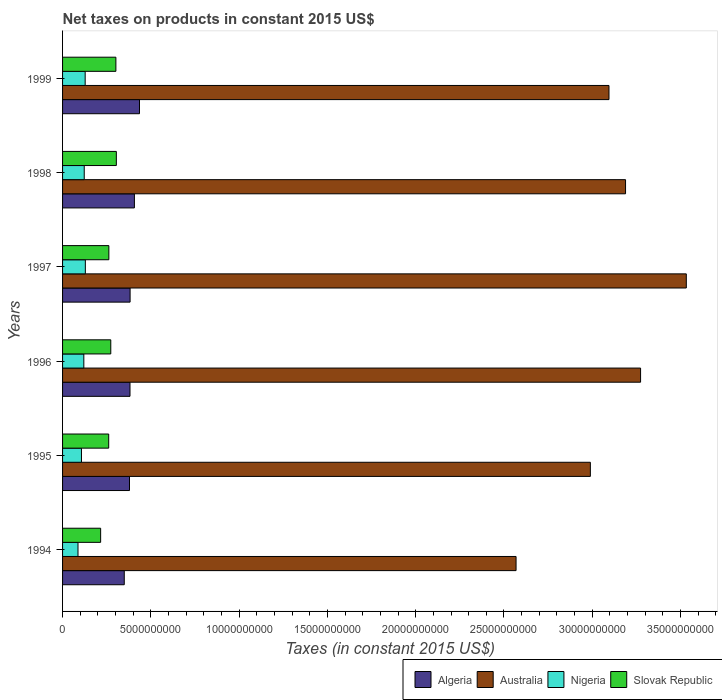How many groups of bars are there?
Offer a terse response. 6. Are the number of bars on each tick of the Y-axis equal?
Keep it short and to the point. Yes. How many bars are there on the 3rd tick from the top?
Your response must be concise. 4. What is the label of the 4th group of bars from the top?
Provide a succinct answer. 1996. In how many cases, is the number of bars for a given year not equal to the number of legend labels?
Ensure brevity in your answer.  0. What is the net taxes on products in Slovak Republic in 1994?
Make the answer very short. 2.16e+09. Across all years, what is the maximum net taxes on products in Algeria?
Give a very brief answer. 4.36e+09. Across all years, what is the minimum net taxes on products in Nigeria?
Your response must be concise. 8.74e+08. In which year was the net taxes on products in Nigeria minimum?
Your answer should be very brief. 1994. What is the total net taxes on products in Australia in the graph?
Your answer should be very brief. 1.86e+11. What is the difference between the net taxes on products in Algeria in 1996 and that in 1998?
Keep it short and to the point. -2.50e+08. What is the difference between the net taxes on products in Algeria in 1996 and the net taxes on products in Slovak Republic in 1999?
Give a very brief answer. 7.99e+08. What is the average net taxes on products in Algeria per year?
Ensure brevity in your answer.  3.89e+09. In the year 1998, what is the difference between the net taxes on products in Australia and net taxes on products in Nigeria?
Keep it short and to the point. 3.07e+1. What is the ratio of the net taxes on products in Algeria in 1994 to that in 1996?
Offer a terse response. 0.91. Is the difference between the net taxes on products in Australia in 1997 and 1998 greater than the difference between the net taxes on products in Nigeria in 1997 and 1998?
Provide a short and direct response. Yes. What is the difference between the highest and the second highest net taxes on products in Australia?
Ensure brevity in your answer.  2.59e+09. What is the difference between the highest and the lowest net taxes on products in Australia?
Offer a very short reply. 9.64e+09. In how many years, is the net taxes on products in Nigeria greater than the average net taxes on products in Nigeria taken over all years?
Make the answer very short. 4. What does the 3rd bar from the top in 1998 represents?
Provide a succinct answer. Australia. What does the 2nd bar from the bottom in 1997 represents?
Provide a succinct answer. Australia. Are all the bars in the graph horizontal?
Offer a very short reply. Yes. How many years are there in the graph?
Your answer should be compact. 6. What is the difference between two consecutive major ticks on the X-axis?
Provide a short and direct response. 5.00e+09. Does the graph contain any zero values?
Give a very brief answer. No. Where does the legend appear in the graph?
Your answer should be compact. Bottom right. What is the title of the graph?
Your response must be concise. Net taxes on products in constant 2015 US$. What is the label or title of the X-axis?
Provide a short and direct response. Taxes (in constant 2015 US$). What is the Taxes (in constant 2015 US$) of Algeria in 1994?
Offer a terse response. 3.49e+09. What is the Taxes (in constant 2015 US$) of Australia in 1994?
Keep it short and to the point. 2.57e+1. What is the Taxes (in constant 2015 US$) in Nigeria in 1994?
Your response must be concise. 8.74e+08. What is the Taxes (in constant 2015 US$) of Slovak Republic in 1994?
Offer a very short reply. 2.16e+09. What is the Taxes (in constant 2015 US$) of Algeria in 1995?
Ensure brevity in your answer.  3.79e+09. What is the Taxes (in constant 2015 US$) in Australia in 1995?
Offer a terse response. 2.99e+1. What is the Taxes (in constant 2015 US$) in Nigeria in 1995?
Make the answer very short. 1.07e+09. What is the Taxes (in constant 2015 US$) of Slovak Republic in 1995?
Your response must be concise. 2.61e+09. What is the Taxes (in constant 2015 US$) in Algeria in 1996?
Your response must be concise. 3.82e+09. What is the Taxes (in constant 2015 US$) in Australia in 1996?
Ensure brevity in your answer.  3.27e+1. What is the Taxes (in constant 2015 US$) in Nigeria in 1996?
Give a very brief answer. 1.20e+09. What is the Taxes (in constant 2015 US$) of Slovak Republic in 1996?
Offer a very short reply. 2.73e+09. What is the Taxes (in constant 2015 US$) of Algeria in 1997?
Ensure brevity in your answer.  3.82e+09. What is the Taxes (in constant 2015 US$) in Australia in 1997?
Your response must be concise. 3.53e+1. What is the Taxes (in constant 2015 US$) of Nigeria in 1997?
Provide a succinct answer. 1.29e+09. What is the Taxes (in constant 2015 US$) of Slovak Republic in 1997?
Provide a short and direct response. 2.62e+09. What is the Taxes (in constant 2015 US$) in Algeria in 1998?
Give a very brief answer. 4.07e+09. What is the Taxes (in constant 2015 US$) of Australia in 1998?
Keep it short and to the point. 3.19e+1. What is the Taxes (in constant 2015 US$) of Nigeria in 1998?
Your response must be concise. 1.23e+09. What is the Taxes (in constant 2015 US$) of Slovak Republic in 1998?
Provide a short and direct response. 3.05e+09. What is the Taxes (in constant 2015 US$) of Algeria in 1999?
Your answer should be very brief. 4.36e+09. What is the Taxes (in constant 2015 US$) in Australia in 1999?
Your response must be concise. 3.09e+1. What is the Taxes (in constant 2015 US$) of Nigeria in 1999?
Provide a short and direct response. 1.28e+09. What is the Taxes (in constant 2015 US$) of Slovak Republic in 1999?
Provide a short and direct response. 3.02e+09. Across all years, what is the maximum Taxes (in constant 2015 US$) in Algeria?
Offer a terse response. 4.36e+09. Across all years, what is the maximum Taxes (in constant 2015 US$) of Australia?
Your response must be concise. 3.53e+1. Across all years, what is the maximum Taxes (in constant 2015 US$) of Nigeria?
Provide a succinct answer. 1.29e+09. Across all years, what is the maximum Taxes (in constant 2015 US$) of Slovak Republic?
Provide a short and direct response. 3.05e+09. Across all years, what is the minimum Taxes (in constant 2015 US$) in Algeria?
Your response must be concise. 3.49e+09. Across all years, what is the minimum Taxes (in constant 2015 US$) in Australia?
Provide a short and direct response. 2.57e+1. Across all years, what is the minimum Taxes (in constant 2015 US$) in Nigeria?
Give a very brief answer. 8.74e+08. Across all years, what is the minimum Taxes (in constant 2015 US$) in Slovak Republic?
Your answer should be very brief. 2.16e+09. What is the total Taxes (in constant 2015 US$) in Algeria in the graph?
Offer a very short reply. 2.34e+1. What is the total Taxes (in constant 2015 US$) of Australia in the graph?
Provide a short and direct response. 1.86e+11. What is the total Taxes (in constant 2015 US$) in Nigeria in the graph?
Provide a short and direct response. 6.95e+09. What is the total Taxes (in constant 2015 US$) in Slovak Republic in the graph?
Your response must be concise. 1.62e+1. What is the difference between the Taxes (in constant 2015 US$) in Algeria in 1994 and that in 1995?
Provide a short and direct response. -2.97e+08. What is the difference between the Taxes (in constant 2015 US$) of Australia in 1994 and that in 1995?
Provide a succinct answer. -4.21e+09. What is the difference between the Taxes (in constant 2015 US$) in Nigeria in 1994 and that in 1995?
Provide a short and direct response. -1.97e+08. What is the difference between the Taxes (in constant 2015 US$) of Slovak Republic in 1994 and that in 1995?
Keep it short and to the point. -4.56e+08. What is the difference between the Taxes (in constant 2015 US$) of Algeria in 1994 and that in 1996?
Offer a very short reply. -3.25e+08. What is the difference between the Taxes (in constant 2015 US$) of Australia in 1994 and that in 1996?
Make the answer very short. -7.05e+09. What is the difference between the Taxes (in constant 2015 US$) in Nigeria in 1994 and that in 1996?
Your answer should be compact. -3.30e+08. What is the difference between the Taxes (in constant 2015 US$) in Slovak Republic in 1994 and that in 1996?
Make the answer very short. -5.74e+08. What is the difference between the Taxes (in constant 2015 US$) in Algeria in 1994 and that in 1997?
Offer a very short reply. -3.30e+08. What is the difference between the Taxes (in constant 2015 US$) in Australia in 1994 and that in 1997?
Your answer should be compact. -9.64e+09. What is the difference between the Taxes (in constant 2015 US$) of Nigeria in 1994 and that in 1997?
Give a very brief answer. -4.16e+08. What is the difference between the Taxes (in constant 2015 US$) in Slovak Republic in 1994 and that in 1997?
Your response must be concise. -4.66e+08. What is the difference between the Taxes (in constant 2015 US$) in Algeria in 1994 and that in 1998?
Give a very brief answer. -5.75e+08. What is the difference between the Taxes (in constant 2015 US$) of Australia in 1994 and that in 1998?
Offer a very short reply. -6.20e+09. What is the difference between the Taxes (in constant 2015 US$) in Nigeria in 1994 and that in 1998?
Ensure brevity in your answer.  -3.53e+08. What is the difference between the Taxes (in constant 2015 US$) in Slovak Republic in 1994 and that in 1998?
Provide a succinct answer. -8.89e+08. What is the difference between the Taxes (in constant 2015 US$) of Algeria in 1994 and that in 1999?
Offer a terse response. -8.63e+08. What is the difference between the Taxes (in constant 2015 US$) of Australia in 1994 and that in 1999?
Keep it short and to the point. -5.26e+09. What is the difference between the Taxes (in constant 2015 US$) of Nigeria in 1994 and that in 1999?
Your response must be concise. -4.06e+08. What is the difference between the Taxes (in constant 2015 US$) in Slovak Republic in 1994 and that in 1999?
Make the answer very short. -8.64e+08. What is the difference between the Taxes (in constant 2015 US$) of Algeria in 1995 and that in 1996?
Your answer should be very brief. -2.80e+07. What is the difference between the Taxes (in constant 2015 US$) of Australia in 1995 and that in 1996?
Your answer should be very brief. -2.84e+09. What is the difference between the Taxes (in constant 2015 US$) in Nigeria in 1995 and that in 1996?
Keep it short and to the point. -1.33e+08. What is the difference between the Taxes (in constant 2015 US$) of Slovak Republic in 1995 and that in 1996?
Offer a very short reply. -1.18e+08. What is the difference between the Taxes (in constant 2015 US$) in Algeria in 1995 and that in 1997?
Offer a terse response. -3.33e+07. What is the difference between the Taxes (in constant 2015 US$) in Australia in 1995 and that in 1997?
Give a very brief answer. -5.43e+09. What is the difference between the Taxes (in constant 2015 US$) in Nigeria in 1995 and that in 1997?
Give a very brief answer. -2.19e+08. What is the difference between the Taxes (in constant 2015 US$) of Slovak Republic in 1995 and that in 1997?
Your answer should be compact. -9.45e+06. What is the difference between the Taxes (in constant 2015 US$) of Algeria in 1995 and that in 1998?
Make the answer very short. -2.78e+08. What is the difference between the Taxes (in constant 2015 US$) of Australia in 1995 and that in 1998?
Ensure brevity in your answer.  -1.99e+09. What is the difference between the Taxes (in constant 2015 US$) in Nigeria in 1995 and that in 1998?
Your response must be concise. -1.56e+08. What is the difference between the Taxes (in constant 2015 US$) of Slovak Republic in 1995 and that in 1998?
Offer a terse response. -4.33e+08. What is the difference between the Taxes (in constant 2015 US$) in Algeria in 1995 and that in 1999?
Provide a succinct answer. -5.66e+08. What is the difference between the Taxes (in constant 2015 US$) of Australia in 1995 and that in 1999?
Your answer should be compact. -1.06e+09. What is the difference between the Taxes (in constant 2015 US$) in Nigeria in 1995 and that in 1999?
Your response must be concise. -2.09e+08. What is the difference between the Taxes (in constant 2015 US$) of Slovak Republic in 1995 and that in 1999?
Offer a very short reply. -4.08e+08. What is the difference between the Taxes (in constant 2015 US$) of Algeria in 1996 and that in 1997?
Offer a terse response. -5.24e+06. What is the difference between the Taxes (in constant 2015 US$) of Australia in 1996 and that in 1997?
Ensure brevity in your answer.  -2.59e+09. What is the difference between the Taxes (in constant 2015 US$) of Nigeria in 1996 and that in 1997?
Offer a terse response. -8.58e+07. What is the difference between the Taxes (in constant 2015 US$) of Slovak Republic in 1996 and that in 1997?
Your answer should be very brief. 1.09e+08. What is the difference between the Taxes (in constant 2015 US$) in Algeria in 1996 and that in 1998?
Offer a terse response. -2.50e+08. What is the difference between the Taxes (in constant 2015 US$) in Australia in 1996 and that in 1998?
Your answer should be compact. 8.52e+08. What is the difference between the Taxes (in constant 2015 US$) of Nigeria in 1996 and that in 1998?
Your answer should be compact. -2.30e+07. What is the difference between the Taxes (in constant 2015 US$) of Slovak Republic in 1996 and that in 1998?
Provide a short and direct response. -3.15e+08. What is the difference between the Taxes (in constant 2015 US$) of Algeria in 1996 and that in 1999?
Your response must be concise. -5.38e+08. What is the difference between the Taxes (in constant 2015 US$) in Australia in 1996 and that in 1999?
Keep it short and to the point. 1.79e+09. What is the difference between the Taxes (in constant 2015 US$) in Nigeria in 1996 and that in 1999?
Offer a very short reply. -7.64e+07. What is the difference between the Taxes (in constant 2015 US$) of Slovak Republic in 1996 and that in 1999?
Keep it short and to the point. -2.89e+08. What is the difference between the Taxes (in constant 2015 US$) of Algeria in 1997 and that in 1998?
Give a very brief answer. -2.44e+08. What is the difference between the Taxes (in constant 2015 US$) of Australia in 1997 and that in 1998?
Offer a very short reply. 3.44e+09. What is the difference between the Taxes (in constant 2015 US$) in Nigeria in 1997 and that in 1998?
Your response must be concise. 6.28e+07. What is the difference between the Taxes (in constant 2015 US$) in Slovak Republic in 1997 and that in 1998?
Make the answer very short. -4.24e+08. What is the difference between the Taxes (in constant 2015 US$) in Algeria in 1997 and that in 1999?
Provide a short and direct response. -5.33e+08. What is the difference between the Taxes (in constant 2015 US$) in Australia in 1997 and that in 1999?
Your answer should be compact. 4.38e+09. What is the difference between the Taxes (in constant 2015 US$) of Nigeria in 1997 and that in 1999?
Offer a very short reply. 9.42e+06. What is the difference between the Taxes (in constant 2015 US$) in Slovak Republic in 1997 and that in 1999?
Give a very brief answer. -3.98e+08. What is the difference between the Taxes (in constant 2015 US$) in Algeria in 1998 and that in 1999?
Provide a short and direct response. -2.89e+08. What is the difference between the Taxes (in constant 2015 US$) of Australia in 1998 and that in 1999?
Provide a short and direct response. 9.37e+08. What is the difference between the Taxes (in constant 2015 US$) of Nigeria in 1998 and that in 1999?
Offer a very short reply. -5.34e+07. What is the difference between the Taxes (in constant 2015 US$) in Slovak Republic in 1998 and that in 1999?
Your response must be concise. 2.57e+07. What is the difference between the Taxes (in constant 2015 US$) in Algeria in 1994 and the Taxes (in constant 2015 US$) in Australia in 1995?
Provide a short and direct response. -2.64e+1. What is the difference between the Taxes (in constant 2015 US$) in Algeria in 1994 and the Taxes (in constant 2015 US$) in Nigeria in 1995?
Your answer should be very brief. 2.42e+09. What is the difference between the Taxes (in constant 2015 US$) of Algeria in 1994 and the Taxes (in constant 2015 US$) of Slovak Republic in 1995?
Offer a terse response. 8.81e+08. What is the difference between the Taxes (in constant 2015 US$) in Australia in 1994 and the Taxes (in constant 2015 US$) in Nigeria in 1995?
Make the answer very short. 2.46e+1. What is the difference between the Taxes (in constant 2015 US$) of Australia in 1994 and the Taxes (in constant 2015 US$) of Slovak Republic in 1995?
Your answer should be compact. 2.31e+1. What is the difference between the Taxes (in constant 2015 US$) in Nigeria in 1994 and the Taxes (in constant 2015 US$) in Slovak Republic in 1995?
Give a very brief answer. -1.74e+09. What is the difference between the Taxes (in constant 2015 US$) in Algeria in 1994 and the Taxes (in constant 2015 US$) in Australia in 1996?
Provide a succinct answer. -2.92e+1. What is the difference between the Taxes (in constant 2015 US$) in Algeria in 1994 and the Taxes (in constant 2015 US$) in Nigeria in 1996?
Your answer should be compact. 2.29e+09. What is the difference between the Taxes (in constant 2015 US$) of Algeria in 1994 and the Taxes (in constant 2015 US$) of Slovak Republic in 1996?
Your answer should be very brief. 7.63e+08. What is the difference between the Taxes (in constant 2015 US$) of Australia in 1994 and the Taxes (in constant 2015 US$) of Nigeria in 1996?
Make the answer very short. 2.45e+1. What is the difference between the Taxes (in constant 2015 US$) in Australia in 1994 and the Taxes (in constant 2015 US$) in Slovak Republic in 1996?
Give a very brief answer. 2.30e+1. What is the difference between the Taxes (in constant 2015 US$) in Nigeria in 1994 and the Taxes (in constant 2015 US$) in Slovak Republic in 1996?
Your answer should be very brief. -1.86e+09. What is the difference between the Taxes (in constant 2015 US$) in Algeria in 1994 and the Taxes (in constant 2015 US$) in Australia in 1997?
Keep it short and to the point. -3.18e+1. What is the difference between the Taxes (in constant 2015 US$) in Algeria in 1994 and the Taxes (in constant 2015 US$) in Nigeria in 1997?
Your answer should be compact. 2.20e+09. What is the difference between the Taxes (in constant 2015 US$) of Algeria in 1994 and the Taxes (in constant 2015 US$) of Slovak Republic in 1997?
Ensure brevity in your answer.  8.72e+08. What is the difference between the Taxes (in constant 2015 US$) of Australia in 1994 and the Taxes (in constant 2015 US$) of Nigeria in 1997?
Your response must be concise. 2.44e+1. What is the difference between the Taxes (in constant 2015 US$) in Australia in 1994 and the Taxes (in constant 2015 US$) in Slovak Republic in 1997?
Your answer should be very brief. 2.31e+1. What is the difference between the Taxes (in constant 2015 US$) of Nigeria in 1994 and the Taxes (in constant 2015 US$) of Slovak Republic in 1997?
Offer a very short reply. -1.75e+09. What is the difference between the Taxes (in constant 2015 US$) in Algeria in 1994 and the Taxes (in constant 2015 US$) in Australia in 1998?
Your answer should be compact. -2.84e+1. What is the difference between the Taxes (in constant 2015 US$) in Algeria in 1994 and the Taxes (in constant 2015 US$) in Nigeria in 1998?
Your answer should be compact. 2.27e+09. What is the difference between the Taxes (in constant 2015 US$) of Algeria in 1994 and the Taxes (in constant 2015 US$) of Slovak Republic in 1998?
Your response must be concise. 4.48e+08. What is the difference between the Taxes (in constant 2015 US$) of Australia in 1994 and the Taxes (in constant 2015 US$) of Nigeria in 1998?
Provide a short and direct response. 2.45e+1. What is the difference between the Taxes (in constant 2015 US$) of Australia in 1994 and the Taxes (in constant 2015 US$) of Slovak Republic in 1998?
Your answer should be compact. 2.26e+1. What is the difference between the Taxes (in constant 2015 US$) of Nigeria in 1994 and the Taxes (in constant 2015 US$) of Slovak Republic in 1998?
Provide a succinct answer. -2.17e+09. What is the difference between the Taxes (in constant 2015 US$) in Algeria in 1994 and the Taxes (in constant 2015 US$) in Australia in 1999?
Offer a very short reply. -2.75e+1. What is the difference between the Taxes (in constant 2015 US$) in Algeria in 1994 and the Taxes (in constant 2015 US$) in Nigeria in 1999?
Your response must be concise. 2.21e+09. What is the difference between the Taxes (in constant 2015 US$) in Algeria in 1994 and the Taxes (in constant 2015 US$) in Slovak Republic in 1999?
Offer a terse response. 4.74e+08. What is the difference between the Taxes (in constant 2015 US$) in Australia in 1994 and the Taxes (in constant 2015 US$) in Nigeria in 1999?
Your response must be concise. 2.44e+1. What is the difference between the Taxes (in constant 2015 US$) of Australia in 1994 and the Taxes (in constant 2015 US$) of Slovak Republic in 1999?
Your answer should be compact. 2.27e+1. What is the difference between the Taxes (in constant 2015 US$) of Nigeria in 1994 and the Taxes (in constant 2015 US$) of Slovak Republic in 1999?
Keep it short and to the point. -2.15e+09. What is the difference between the Taxes (in constant 2015 US$) in Algeria in 1995 and the Taxes (in constant 2015 US$) in Australia in 1996?
Your answer should be compact. -2.89e+1. What is the difference between the Taxes (in constant 2015 US$) in Algeria in 1995 and the Taxes (in constant 2015 US$) in Nigeria in 1996?
Your answer should be compact. 2.59e+09. What is the difference between the Taxes (in constant 2015 US$) of Algeria in 1995 and the Taxes (in constant 2015 US$) of Slovak Republic in 1996?
Provide a succinct answer. 1.06e+09. What is the difference between the Taxes (in constant 2015 US$) of Australia in 1995 and the Taxes (in constant 2015 US$) of Nigeria in 1996?
Make the answer very short. 2.87e+1. What is the difference between the Taxes (in constant 2015 US$) in Australia in 1995 and the Taxes (in constant 2015 US$) in Slovak Republic in 1996?
Provide a short and direct response. 2.72e+1. What is the difference between the Taxes (in constant 2015 US$) of Nigeria in 1995 and the Taxes (in constant 2015 US$) of Slovak Republic in 1996?
Offer a terse response. -1.66e+09. What is the difference between the Taxes (in constant 2015 US$) in Algeria in 1995 and the Taxes (in constant 2015 US$) in Australia in 1997?
Provide a succinct answer. -3.15e+1. What is the difference between the Taxes (in constant 2015 US$) of Algeria in 1995 and the Taxes (in constant 2015 US$) of Nigeria in 1997?
Provide a succinct answer. 2.50e+09. What is the difference between the Taxes (in constant 2015 US$) of Algeria in 1995 and the Taxes (in constant 2015 US$) of Slovak Republic in 1997?
Your answer should be compact. 1.17e+09. What is the difference between the Taxes (in constant 2015 US$) in Australia in 1995 and the Taxes (in constant 2015 US$) in Nigeria in 1997?
Keep it short and to the point. 2.86e+1. What is the difference between the Taxes (in constant 2015 US$) of Australia in 1995 and the Taxes (in constant 2015 US$) of Slovak Republic in 1997?
Provide a succinct answer. 2.73e+1. What is the difference between the Taxes (in constant 2015 US$) of Nigeria in 1995 and the Taxes (in constant 2015 US$) of Slovak Republic in 1997?
Make the answer very short. -1.55e+09. What is the difference between the Taxes (in constant 2015 US$) in Algeria in 1995 and the Taxes (in constant 2015 US$) in Australia in 1998?
Give a very brief answer. -2.81e+1. What is the difference between the Taxes (in constant 2015 US$) of Algeria in 1995 and the Taxes (in constant 2015 US$) of Nigeria in 1998?
Provide a succinct answer. 2.56e+09. What is the difference between the Taxes (in constant 2015 US$) in Algeria in 1995 and the Taxes (in constant 2015 US$) in Slovak Republic in 1998?
Provide a succinct answer. 7.45e+08. What is the difference between the Taxes (in constant 2015 US$) of Australia in 1995 and the Taxes (in constant 2015 US$) of Nigeria in 1998?
Provide a succinct answer. 2.87e+1. What is the difference between the Taxes (in constant 2015 US$) of Australia in 1995 and the Taxes (in constant 2015 US$) of Slovak Republic in 1998?
Your answer should be very brief. 2.68e+1. What is the difference between the Taxes (in constant 2015 US$) in Nigeria in 1995 and the Taxes (in constant 2015 US$) in Slovak Republic in 1998?
Your answer should be compact. -1.98e+09. What is the difference between the Taxes (in constant 2015 US$) in Algeria in 1995 and the Taxes (in constant 2015 US$) in Australia in 1999?
Offer a very short reply. -2.72e+1. What is the difference between the Taxes (in constant 2015 US$) in Algeria in 1995 and the Taxes (in constant 2015 US$) in Nigeria in 1999?
Keep it short and to the point. 2.51e+09. What is the difference between the Taxes (in constant 2015 US$) of Algeria in 1995 and the Taxes (in constant 2015 US$) of Slovak Republic in 1999?
Offer a terse response. 7.71e+08. What is the difference between the Taxes (in constant 2015 US$) in Australia in 1995 and the Taxes (in constant 2015 US$) in Nigeria in 1999?
Provide a succinct answer. 2.86e+1. What is the difference between the Taxes (in constant 2015 US$) in Australia in 1995 and the Taxes (in constant 2015 US$) in Slovak Republic in 1999?
Provide a short and direct response. 2.69e+1. What is the difference between the Taxes (in constant 2015 US$) of Nigeria in 1995 and the Taxes (in constant 2015 US$) of Slovak Republic in 1999?
Provide a short and direct response. -1.95e+09. What is the difference between the Taxes (in constant 2015 US$) in Algeria in 1996 and the Taxes (in constant 2015 US$) in Australia in 1997?
Offer a terse response. -3.15e+1. What is the difference between the Taxes (in constant 2015 US$) in Algeria in 1996 and the Taxes (in constant 2015 US$) in Nigeria in 1997?
Offer a very short reply. 2.53e+09. What is the difference between the Taxes (in constant 2015 US$) in Algeria in 1996 and the Taxes (in constant 2015 US$) in Slovak Republic in 1997?
Your answer should be compact. 1.20e+09. What is the difference between the Taxes (in constant 2015 US$) of Australia in 1996 and the Taxes (in constant 2015 US$) of Nigeria in 1997?
Your answer should be very brief. 3.14e+1. What is the difference between the Taxes (in constant 2015 US$) in Australia in 1996 and the Taxes (in constant 2015 US$) in Slovak Republic in 1997?
Give a very brief answer. 3.01e+1. What is the difference between the Taxes (in constant 2015 US$) of Nigeria in 1996 and the Taxes (in constant 2015 US$) of Slovak Republic in 1997?
Make the answer very short. -1.42e+09. What is the difference between the Taxes (in constant 2015 US$) of Algeria in 1996 and the Taxes (in constant 2015 US$) of Australia in 1998?
Provide a short and direct response. -2.81e+1. What is the difference between the Taxes (in constant 2015 US$) of Algeria in 1996 and the Taxes (in constant 2015 US$) of Nigeria in 1998?
Your response must be concise. 2.59e+09. What is the difference between the Taxes (in constant 2015 US$) in Algeria in 1996 and the Taxes (in constant 2015 US$) in Slovak Republic in 1998?
Your answer should be very brief. 7.73e+08. What is the difference between the Taxes (in constant 2015 US$) in Australia in 1996 and the Taxes (in constant 2015 US$) in Nigeria in 1998?
Keep it short and to the point. 3.15e+1. What is the difference between the Taxes (in constant 2015 US$) of Australia in 1996 and the Taxes (in constant 2015 US$) of Slovak Republic in 1998?
Make the answer very short. 2.97e+1. What is the difference between the Taxes (in constant 2015 US$) of Nigeria in 1996 and the Taxes (in constant 2015 US$) of Slovak Republic in 1998?
Keep it short and to the point. -1.84e+09. What is the difference between the Taxes (in constant 2015 US$) in Algeria in 1996 and the Taxes (in constant 2015 US$) in Australia in 1999?
Your response must be concise. -2.71e+1. What is the difference between the Taxes (in constant 2015 US$) in Algeria in 1996 and the Taxes (in constant 2015 US$) in Nigeria in 1999?
Offer a very short reply. 2.54e+09. What is the difference between the Taxes (in constant 2015 US$) in Algeria in 1996 and the Taxes (in constant 2015 US$) in Slovak Republic in 1999?
Your answer should be very brief. 7.99e+08. What is the difference between the Taxes (in constant 2015 US$) in Australia in 1996 and the Taxes (in constant 2015 US$) in Nigeria in 1999?
Make the answer very short. 3.15e+1. What is the difference between the Taxes (in constant 2015 US$) of Australia in 1996 and the Taxes (in constant 2015 US$) of Slovak Republic in 1999?
Your answer should be very brief. 2.97e+1. What is the difference between the Taxes (in constant 2015 US$) in Nigeria in 1996 and the Taxes (in constant 2015 US$) in Slovak Republic in 1999?
Keep it short and to the point. -1.82e+09. What is the difference between the Taxes (in constant 2015 US$) in Algeria in 1997 and the Taxes (in constant 2015 US$) in Australia in 1998?
Keep it short and to the point. -2.81e+1. What is the difference between the Taxes (in constant 2015 US$) in Algeria in 1997 and the Taxes (in constant 2015 US$) in Nigeria in 1998?
Your response must be concise. 2.60e+09. What is the difference between the Taxes (in constant 2015 US$) in Algeria in 1997 and the Taxes (in constant 2015 US$) in Slovak Republic in 1998?
Make the answer very short. 7.78e+08. What is the difference between the Taxes (in constant 2015 US$) of Australia in 1997 and the Taxes (in constant 2015 US$) of Nigeria in 1998?
Ensure brevity in your answer.  3.41e+1. What is the difference between the Taxes (in constant 2015 US$) in Australia in 1997 and the Taxes (in constant 2015 US$) in Slovak Republic in 1998?
Your answer should be very brief. 3.23e+1. What is the difference between the Taxes (in constant 2015 US$) of Nigeria in 1997 and the Taxes (in constant 2015 US$) of Slovak Republic in 1998?
Your answer should be very brief. -1.76e+09. What is the difference between the Taxes (in constant 2015 US$) in Algeria in 1997 and the Taxes (in constant 2015 US$) in Australia in 1999?
Keep it short and to the point. -2.71e+1. What is the difference between the Taxes (in constant 2015 US$) in Algeria in 1997 and the Taxes (in constant 2015 US$) in Nigeria in 1999?
Ensure brevity in your answer.  2.54e+09. What is the difference between the Taxes (in constant 2015 US$) of Algeria in 1997 and the Taxes (in constant 2015 US$) of Slovak Republic in 1999?
Keep it short and to the point. 8.04e+08. What is the difference between the Taxes (in constant 2015 US$) of Australia in 1997 and the Taxes (in constant 2015 US$) of Nigeria in 1999?
Your answer should be very brief. 3.40e+1. What is the difference between the Taxes (in constant 2015 US$) of Australia in 1997 and the Taxes (in constant 2015 US$) of Slovak Republic in 1999?
Your response must be concise. 3.23e+1. What is the difference between the Taxes (in constant 2015 US$) in Nigeria in 1997 and the Taxes (in constant 2015 US$) in Slovak Republic in 1999?
Offer a very short reply. -1.73e+09. What is the difference between the Taxes (in constant 2015 US$) of Algeria in 1998 and the Taxes (in constant 2015 US$) of Australia in 1999?
Offer a very short reply. -2.69e+1. What is the difference between the Taxes (in constant 2015 US$) in Algeria in 1998 and the Taxes (in constant 2015 US$) in Nigeria in 1999?
Give a very brief answer. 2.79e+09. What is the difference between the Taxes (in constant 2015 US$) of Algeria in 1998 and the Taxes (in constant 2015 US$) of Slovak Republic in 1999?
Your response must be concise. 1.05e+09. What is the difference between the Taxes (in constant 2015 US$) in Australia in 1998 and the Taxes (in constant 2015 US$) in Nigeria in 1999?
Give a very brief answer. 3.06e+1. What is the difference between the Taxes (in constant 2015 US$) of Australia in 1998 and the Taxes (in constant 2015 US$) of Slovak Republic in 1999?
Your response must be concise. 2.89e+1. What is the difference between the Taxes (in constant 2015 US$) of Nigeria in 1998 and the Taxes (in constant 2015 US$) of Slovak Republic in 1999?
Keep it short and to the point. -1.79e+09. What is the average Taxes (in constant 2015 US$) in Algeria per year?
Keep it short and to the point. 3.89e+09. What is the average Taxes (in constant 2015 US$) in Australia per year?
Provide a succinct answer. 3.11e+1. What is the average Taxes (in constant 2015 US$) in Nigeria per year?
Your answer should be very brief. 1.16e+09. What is the average Taxes (in constant 2015 US$) in Slovak Republic per year?
Make the answer very short. 2.70e+09. In the year 1994, what is the difference between the Taxes (in constant 2015 US$) of Algeria and Taxes (in constant 2015 US$) of Australia?
Provide a short and direct response. -2.22e+1. In the year 1994, what is the difference between the Taxes (in constant 2015 US$) of Algeria and Taxes (in constant 2015 US$) of Nigeria?
Your answer should be very brief. 2.62e+09. In the year 1994, what is the difference between the Taxes (in constant 2015 US$) of Algeria and Taxes (in constant 2015 US$) of Slovak Republic?
Ensure brevity in your answer.  1.34e+09. In the year 1994, what is the difference between the Taxes (in constant 2015 US$) in Australia and Taxes (in constant 2015 US$) in Nigeria?
Your answer should be compact. 2.48e+1. In the year 1994, what is the difference between the Taxes (in constant 2015 US$) of Australia and Taxes (in constant 2015 US$) of Slovak Republic?
Offer a very short reply. 2.35e+1. In the year 1994, what is the difference between the Taxes (in constant 2015 US$) in Nigeria and Taxes (in constant 2015 US$) in Slovak Republic?
Provide a short and direct response. -1.28e+09. In the year 1995, what is the difference between the Taxes (in constant 2015 US$) in Algeria and Taxes (in constant 2015 US$) in Australia?
Offer a very short reply. -2.61e+1. In the year 1995, what is the difference between the Taxes (in constant 2015 US$) of Algeria and Taxes (in constant 2015 US$) of Nigeria?
Your answer should be very brief. 2.72e+09. In the year 1995, what is the difference between the Taxes (in constant 2015 US$) in Algeria and Taxes (in constant 2015 US$) in Slovak Republic?
Provide a succinct answer. 1.18e+09. In the year 1995, what is the difference between the Taxes (in constant 2015 US$) in Australia and Taxes (in constant 2015 US$) in Nigeria?
Offer a terse response. 2.88e+1. In the year 1995, what is the difference between the Taxes (in constant 2015 US$) in Australia and Taxes (in constant 2015 US$) in Slovak Republic?
Your answer should be compact. 2.73e+1. In the year 1995, what is the difference between the Taxes (in constant 2015 US$) of Nigeria and Taxes (in constant 2015 US$) of Slovak Republic?
Offer a terse response. -1.54e+09. In the year 1996, what is the difference between the Taxes (in constant 2015 US$) of Algeria and Taxes (in constant 2015 US$) of Australia?
Offer a terse response. -2.89e+1. In the year 1996, what is the difference between the Taxes (in constant 2015 US$) of Algeria and Taxes (in constant 2015 US$) of Nigeria?
Keep it short and to the point. 2.62e+09. In the year 1996, what is the difference between the Taxes (in constant 2015 US$) in Algeria and Taxes (in constant 2015 US$) in Slovak Republic?
Keep it short and to the point. 1.09e+09. In the year 1996, what is the difference between the Taxes (in constant 2015 US$) in Australia and Taxes (in constant 2015 US$) in Nigeria?
Offer a terse response. 3.15e+1. In the year 1996, what is the difference between the Taxes (in constant 2015 US$) of Australia and Taxes (in constant 2015 US$) of Slovak Republic?
Your answer should be compact. 3.00e+1. In the year 1996, what is the difference between the Taxes (in constant 2015 US$) in Nigeria and Taxes (in constant 2015 US$) in Slovak Republic?
Ensure brevity in your answer.  -1.53e+09. In the year 1997, what is the difference between the Taxes (in constant 2015 US$) in Algeria and Taxes (in constant 2015 US$) in Australia?
Your answer should be very brief. -3.15e+1. In the year 1997, what is the difference between the Taxes (in constant 2015 US$) of Algeria and Taxes (in constant 2015 US$) of Nigeria?
Offer a very short reply. 2.53e+09. In the year 1997, what is the difference between the Taxes (in constant 2015 US$) in Algeria and Taxes (in constant 2015 US$) in Slovak Republic?
Offer a terse response. 1.20e+09. In the year 1997, what is the difference between the Taxes (in constant 2015 US$) of Australia and Taxes (in constant 2015 US$) of Nigeria?
Ensure brevity in your answer.  3.40e+1. In the year 1997, what is the difference between the Taxes (in constant 2015 US$) in Australia and Taxes (in constant 2015 US$) in Slovak Republic?
Offer a very short reply. 3.27e+1. In the year 1997, what is the difference between the Taxes (in constant 2015 US$) of Nigeria and Taxes (in constant 2015 US$) of Slovak Republic?
Provide a succinct answer. -1.33e+09. In the year 1998, what is the difference between the Taxes (in constant 2015 US$) of Algeria and Taxes (in constant 2015 US$) of Australia?
Provide a short and direct response. -2.78e+1. In the year 1998, what is the difference between the Taxes (in constant 2015 US$) in Algeria and Taxes (in constant 2015 US$) in Nigeria?
Make the answer very short. 2.84e+09. In the year 1998, what is the difference between the Taxes (in constant 2015 US$) in Algeria and Taxes (in constant 2015 US$) in Slovak Republic?
Make the answer very short. 1.02e+09. In the year 1998, what is the difference between the Taxes (in constant 2015 US$) of Australia and Taxes (in constant 2015 US$) of Nigeria?
Offer a very short reply. 3.07e+1. In the year 1998, what is the difference between the Taxes (in constant 2015 US$) in Australia and Taxes (in constant 2015 US$) in Slovak Republic?
Ensure brevity in your answer.  2.88e+1. In the year 1998, what is the difference between the Taxes (in constant 2015 US$) of Nigeria and Taxes (in constant 2015 US$) of Slovak Republic?
Make the answer very short. -1.82e+09. In the year 1999, what is the difference between the Taxes (in constant 2015 US$) of Algeria and Taxes (in constant 2015 US$) of Australia?
Your answer should be compact. -2.66e+1. In the year 1999, what is the difference between the Taxes (in constant 2015 US$) of Algeria and Taxes (in constant 2015 US$) of Nigeria?
Your answer should be very brief. 3.08e+09. In the year 1999, what is the difference between the Taxes (in constant 2015 US$) in Algeria and Taxes (in constant 2015 US$) in Slovak Republic?
Give a very brief answer. 1.34e+09. In the year 1999, what is the difference between the Taxes (in constant 2015 US$) of Australia and Taxes (in constant 2015 US$) of Nigeria?
Your answer should be compact. 2.97e+1. In the year 1999, what is the difference between the Taxes (in constant 2015 US$) of Australia and Taxes (in constant 2015 US$) of Slovak Republic?
Offer a terse response. 2.79e+1. In the year 1999, what is the difference between the Taxes (in constant 2015 US$) in Nigeria and Taxes (in constant 2015 US$) in Slovak Republic?
Your answer should be compact. -1.74e+09. What is the ratio of the Taxes (in constant 2015 US$) in Algeria in 1994 to that in 1995?
Offer a terse response. 0.92. What is the ratio of the Taxes (in constant 2015 US$) in Australia in 1994 to that in 1995?
Offer a terse response. 0.86. What is the ratio of the Taxes (in constant 2015 US$) of Nigeria in 1994 to that in 1995?
Keep it short and to the point. 0.82. What is the ratio of the Taxes (in constant 2015 US$) of Slovak Republic in 1994 to that in 1995?
Ensure brevity in your answer.  0.83. What is the ratio of the Taxes (in constant 2015 US$) in Algeria in 1994 to that in 1996?
Your answer should be compact. 0.91. What is the ratio of the Taxes (in constant 2015 US$) in Australia in 1994 to that in 1996?
Your answer should be compact. 0.78. What is the ratio of the Taxes (in constant 2015 US$) in Nigeria in 1994 to that in 1996?
Make the answer very short. 0.73. What is the ratio of the Taxes (in constant 2015 US$) in Slovak Republic in 1994 to that in 1996?
Your answer should be compact. 0.79. What is the ratio of the Taxes (in constant 2015 US$) in Algeria in 1994 to that in 1997?
Ensure brevity in your answer.  0.91. What is the ratio of the Taxes (in constant 2015 US$) of Australia in 1994 to that in 1997?
Give a very brief answer. 0.73. What is the ratio of the Taxes (in constant 2015 US$) in Nigeria in 1994 to that in 1997?
Your answer should be very brief. 0.68. What is the ratio of the Taxes (in constant 2015 US$) of Slovak Republic in 1994 to that in 1997?
Offer a very short reply. 0.82. What is the ratio of the Taxes (in constant 2015 US$) in Algeria in 1994 to that in 1998?
Offer a very short reply. 0.86. What is the ratio of the Taxes (in constant 2015 US$) of Australia in 1994 to that in 1998?
Keep it short and to the point. 0.81. What is the ratio of the Taxes (in constant 2015 US$) of Nigeria in 1994 to that in 1998?
Your answer should be very brief. 0.71. What is the ratio of the Taxes (in constant 2015 US$) of Slovak Republic in 1994 to that in 1998?
Make the answer very short. 0.71. What is the ratio of the Taxes (in constant 2015 US$) of Algeria in 1994 to that in 1999?
Provide a short and direct response. 0.8. What is the ratio of the Taxes (in constant 2015 US$) in Australia in 1994 to that in 1999?
Provide a succinct answer. 0.83. What is the ratio of the Taxes (in constant 2015 US$) of Nigeria in 1994 to that in 1999?
Offer a terse response. 0.68. What is the ratio of the Taxes (in constant 2015 US$) of Slovak Republic in 1994 to that in 1999?
Give a very brief answer. 0.71. What is the ratio of the Taxes (in constant 2015 US$) of Algeria in 1995 to that in 1996?
Keep it short and to the point. 0.99. What is the ratio of the Taxes (in constant 2015 US$) in Australia in 1995 to that in 1996?
Offer a very short reply. 0.91. What is the ratio of the Taxes (in constant 2015 US$) of Nigeria in 1995 to that in 1996?
Provide a succinct answer. 0.89. What is the ratio of the Taxes (in constant 2015 US$) in Slovak Republic in 1995 to that in 1996?
Offer a terse response. 0.96. What is the ratio of the Taxes (in constant 2015 US$) in Algeria in 1995 to that in 1997?
Provide a succinct answer. 0.99. What is the ratio of the Taxes (in constant 2015 US$) in Australia in 1995 to that in 1997?
Your response must be concise. 0.85. What is the ratio of the Taxes (in constant 2015 US$) in Nigeria in 1995 to that in 1997?
Offer a terse response. 0.83. What is the ratio of the Taxes (in constant 2015 US$) in Slovak Republic in 1995 to that in 1997?
Give a very brief answer. 1. What is the ratio of the Taxes (in constant 2015 US$) in Algeria in 1995 to that in 1998?
Make the answer very short. 0.93. What is the ratio of the Taxes (in constant 2015 US$) of Australia in 1995 to that in 1998?
Keep it short and to the point. 0.94. What is the ratio of the Taxes (in constant 2015 US$) in Nigeria in 1995 to that in 1998?
Offer a terse response. 0.87. What is the ratio of the Taxes (in constant 2015 US$) of Slovak Republic in 1995 to that in 1998?
Your response must be concise. 0.86. What is the ratio of the Taxes (in constant 2015 US$) in Algeria in 1995 to that in 1999?
Ensure brevity in your answer.  0.87. What is the ratio of the Taxes (in constant 2015 US$) of Australia in 1995 to that in 1999?
Provide a succinct answer. 0.97. What is the ratio of the Taxes (in constant 2015 US$) of Nigeria in 1995 to that in 1999?
Provide a succinct answer. 0.84. What is the ratio of the Taxes (in constant 2015 US$) of Slovak Republic in 1995 to that in 1999?
Make the answer very short. 0.87. What is the ratio of the Taxes (in constant 2015 US$) in Algeria in 1996 to that in 1997?
Keep it short and to the point. 1. What is the ratio of the Taxes (in constant 2015 US$) in Australia in 1996 to that in 1997?
Provide a succinct answer. 0.93. What is the ratio of the Taxes (in constant 2015 US$) in Nigeria in 1996 to that in 1997?
Your response must be concise. 0.93. What is the ratio of the Taxes (in constant 2015 US$) of Slovak Republic in 1996 to that in 1997?
Your response must be concise. 1.04. What is the ratio of the Taxes (in constant 2015 US$) of Algeria in 1996 to that in 1998?
Offer a very short reply. 0.94. What is the ratio of the Taxes (in constant 2015 US$) in Australia in 1996 to that in 1998?
Keep it short and to the point. 1.03. What is the ratio of the Taxes (in constant 2015 US$) in Nigeria in 1996 to that in 1998?
Your answer should be very brief. 0.98. What is the ratio of the Taxes (in constant 2015 US$) in Slovak Republic in 1996 to that in 1998?
Offer a terse response. 0.9. What is the ratio of the Taxes (in constant 2015 US$) in Algeria in 1996 to that in 1999?
Your response must be concise. 0.88. What is the ratio of the Taxes (in constant 2015 US$) in Australia in 1996 to that in 1999?
Provide a succinct answer. 1.06. What is the ratio of the Taxes (in constant 2015 US$) of Nigeria in 1996 to that in 1999?
Ensure brevity in your answer.  0.94. What is the ratio of the Taxes (in constant 2015 US$) of Slovak Republic in 1996 to that in 1999?
Offer a very short reply. 0.9. What is the ratio of the Taxes (in constant 2015 US$) in Algeria in 1997 to that in 1998?
Make the answer very short. 0.94. What is the ratio of the Taxes (in constant 2015 US$) in Australia in 1997 to that in 1998?
Make the answer very short. 1.11. What is the ratio of the Taxes (in constant 2015 US$) of Nigeria in 1997 to that in 1998?
Your answer should be compact. 1.05. What is the ratio of the Taxes (in constant 2015 US$) of Slovak Republic in 1997 to that in 1998?
Make the answer very short. 0.86. What is the ratio of the Taxes (in constant 2015 US$) of Algeria in 1997 to that in 1999?
Keep it short and to the point. 0.88. What is the ratio of the Taxes (in constant 2015 US$) in Australia in 1997 to that in 1999?
Your answer should be very brief. 1.14. What is the ratio of the Taxes (in constant 2015 US$) in Nigeria in 1997 to that in 1999?
Provide a succinct answer. 1.01. What is the ratio of the Taxes (in constant 2015 US$) of Slovak Republic in 1997 to that in 1999?
Give a very brief answer. 0.87. What is the ratio of the Taxes (in constant 2015 US$) in Algeria in 1998 to that in 1999?
Offer a terse response. 0.93. What is the ratio of the Taxes (in constant 2015 US$) in Australia in 1998 to that in 1999?
Your answer should be very brief. 1.03. What is the ratio of the Taxes (in constant 2015 US$) in Slovak Republic in 1998 to that in 1999?
Your response must be concise. 1.01. What is the difference between the highest and the second highest Taxes (in constant 2015 US$) in Algeria?
Your response must be concise. 2.89e+08. What is the difference between the highest and the second highest Taxes (in constant 2015 US$) of Australia?
Your response must be concise. 2.59e+09. What is the difference between the highest and the second highest Taxes (in constant 2015 US$) of Nigeria?
Your response must be concise. 9.42e+06. What is the difference between the highest and the second highest Taxes (in constant 2015 US$) in Slovak Republic?
Your response must be concise. 2.57e+07. What is the difference between the highest and the lowest Taxes (in constant 2015 US$) in Algeria?
Provide a succinct answer. 8.63e+08. What is the difference between the highest and the lowest Taxes (in constant 2015 US$) in Australia?
Offer a very short reply. 9.64e+09. What is the difference between the highest and the lowest Taxes (in constant 2015 US$) of Nigeria?
Give a very brief answer. 4.16e+08. What is the difference between the highest and the lowest Taxes (in constant 2015 US$) in Slovak Republic?
Make the answer very short. 8.89e+08. 